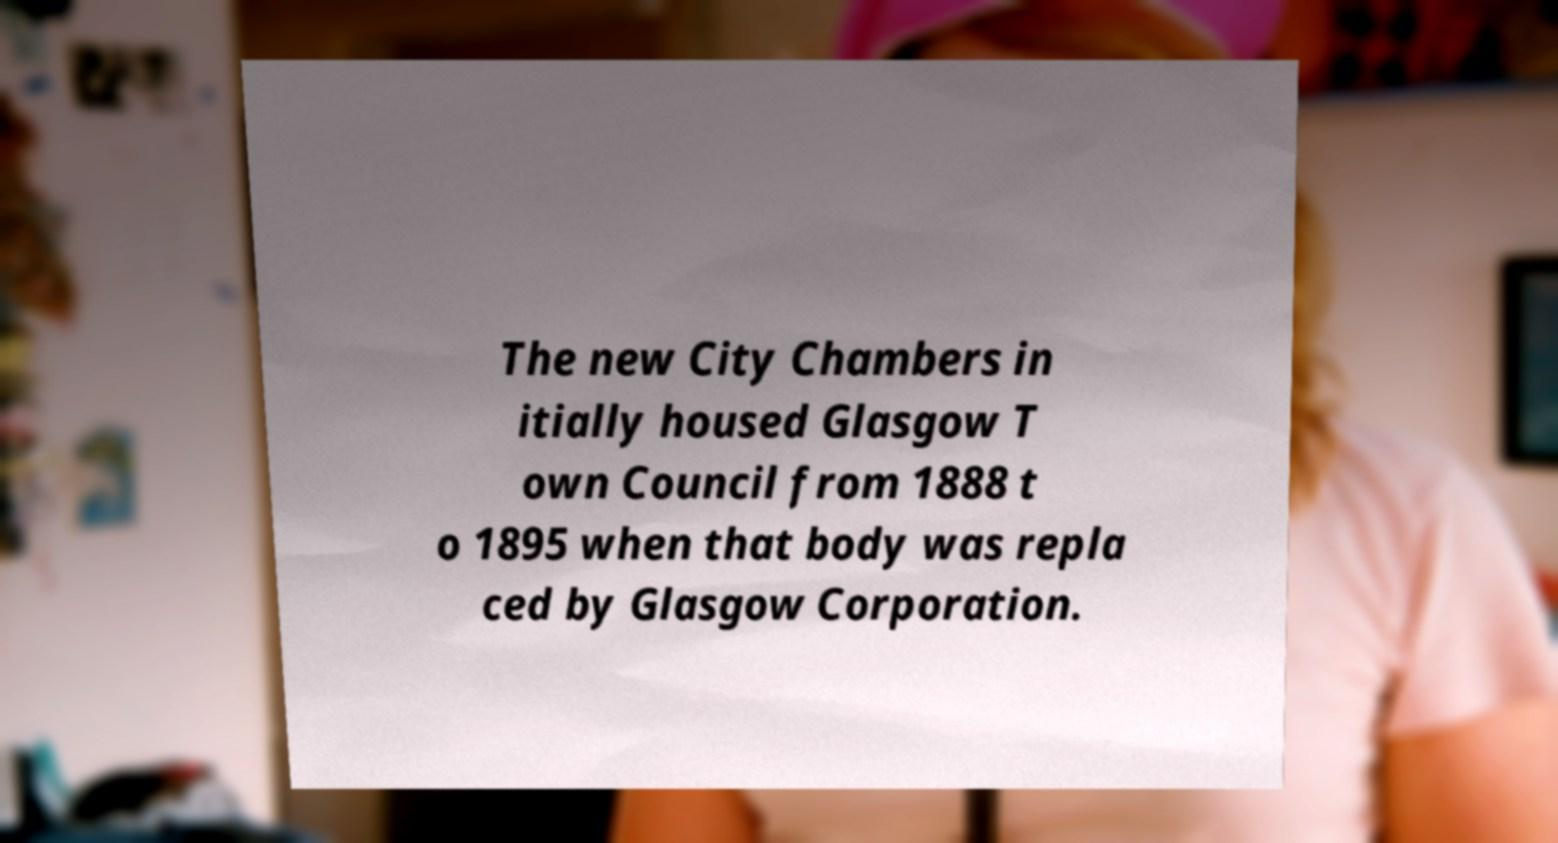I need the written content from this picture converted into text. Can you do that? The new City Chambers in itially housed Glasgow T own Council from 1888 t o 1895 when that body was repla ced by Glasgow Corporation. 